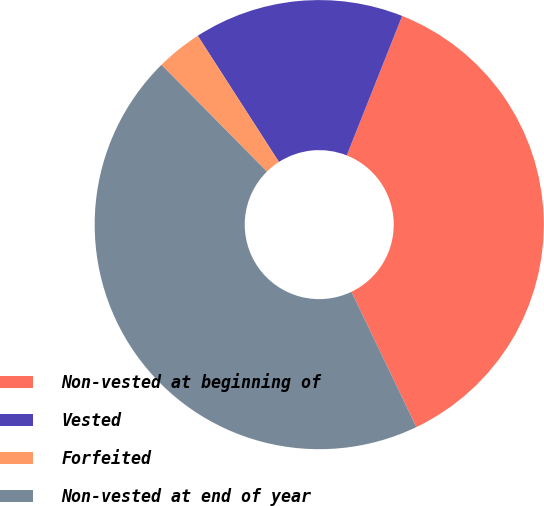Convert chart to OTSL. <chart><loc_0><loc_0><loc_500><loc_500><pie_chart><fcel>Non-vested at beginning of<fcel>Vested<fcel>Forfeited<fcel>Non-vested at end of year<nl><fcel>36.86%<fcel>15.12%<fcel>3.3%<fcel>44.72%<nl></chart> 